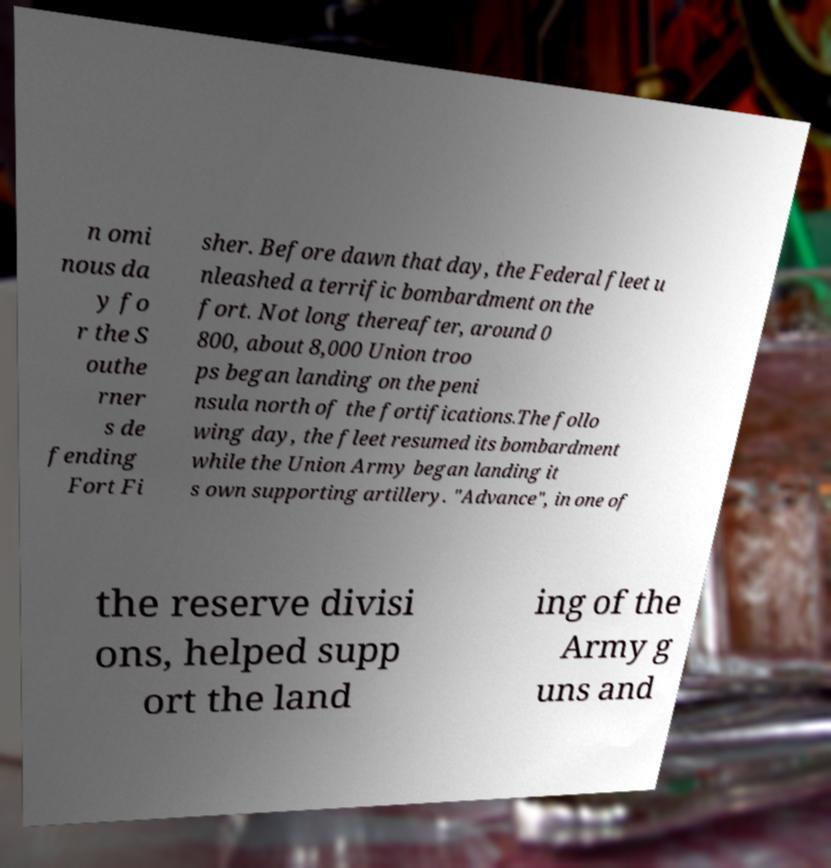What messages or text are displayed in this image? I need them in a readable, typed format. n omi nous da y fo r the S outhe rner s de fending Fort Fi sher. Before dawn that day, the Federal fleet u nleashed a terrific bombardment on the fort. Not long thereafter, around 0 800, about 8,000 Union troo ps began landing on the peni nsula north of the fortifications.The follo wing day, the fleet resumed its bombardment while the Union Army began landing it s own supporting artillery. "Advance", in one of the reserve divisi ons, helped supp ort the land ing of the Army g uns and 